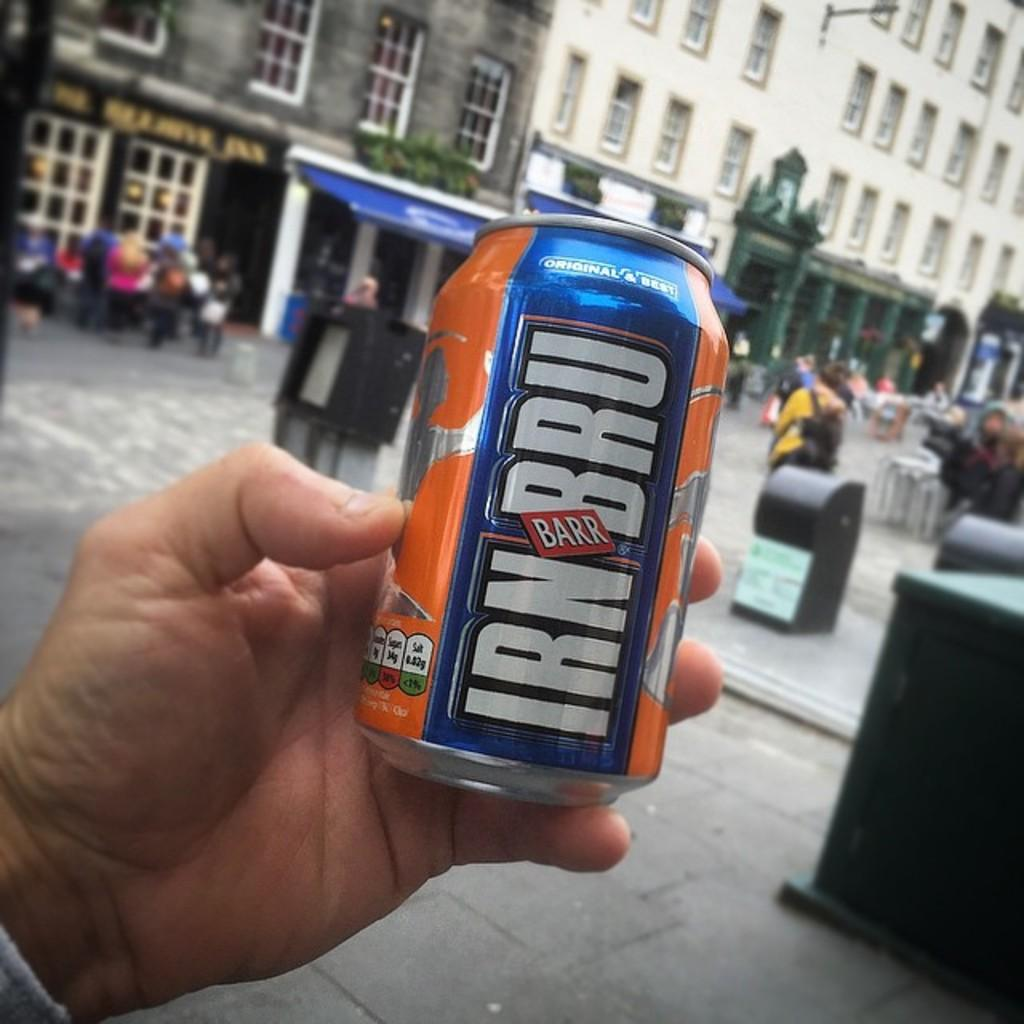<image>
Provide a brief description of the given image. A man carries a can of Irn Bru on the street. 